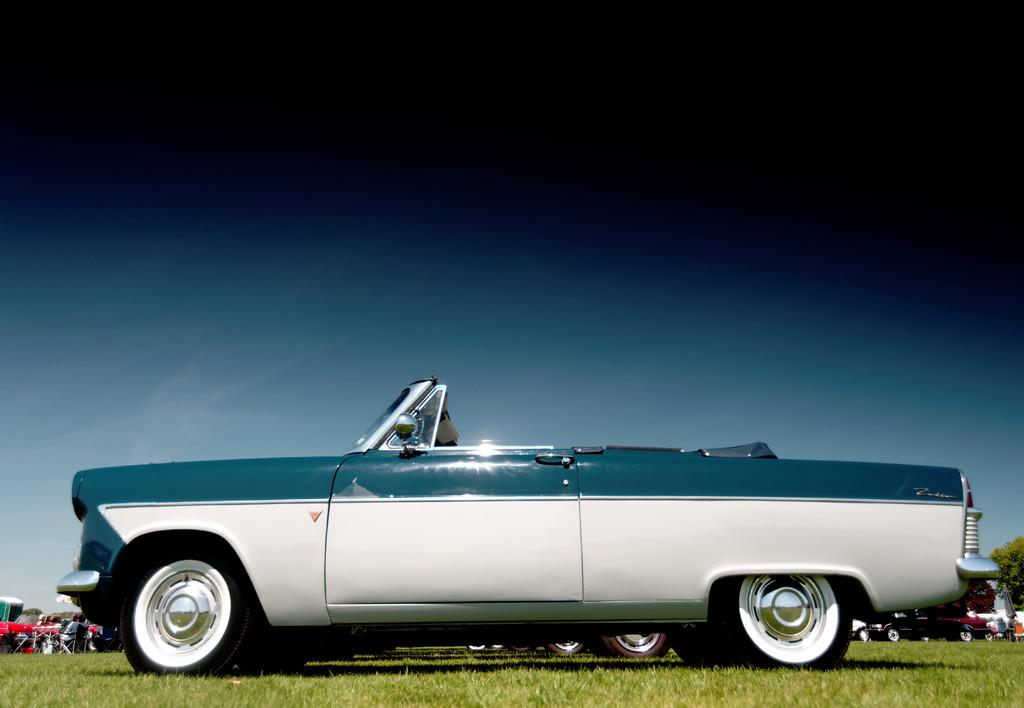What is the main subject of focus of the image? The main focus of the image is the many vehicles on the grass. Are there any people present in the image? Yes, there are people visible in the image. What can be seen in the background of the image? There are many trees and the sky visible in the background of the image. What type of steel is used to construct the cub in the image? There is no cub present in the image, and therefore no steel construction can be observed. 